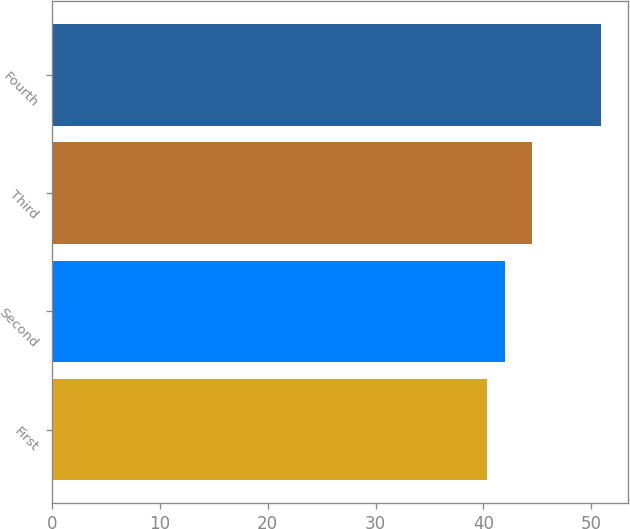Convert chart. <chart><loc_0><loc_0><loc_500><loc_500><bar_chart><fcel>First<fcel>Second<fcel>Third<fcel>Fourth<nl><fcel>40.37<fcel>42<fcel>44.51<fcel>50.9<nl></chart> 